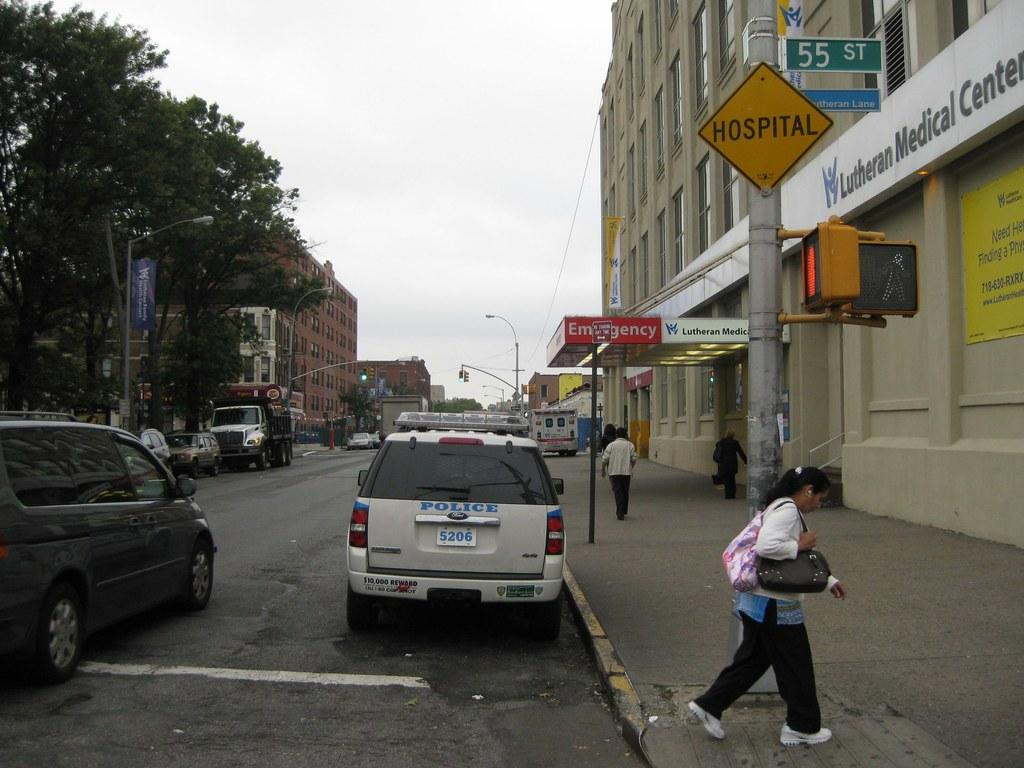<image>
Present a compact description of the photo's key features. A woman walks under a yellow sign that displays the word HOSPITAL on it. 